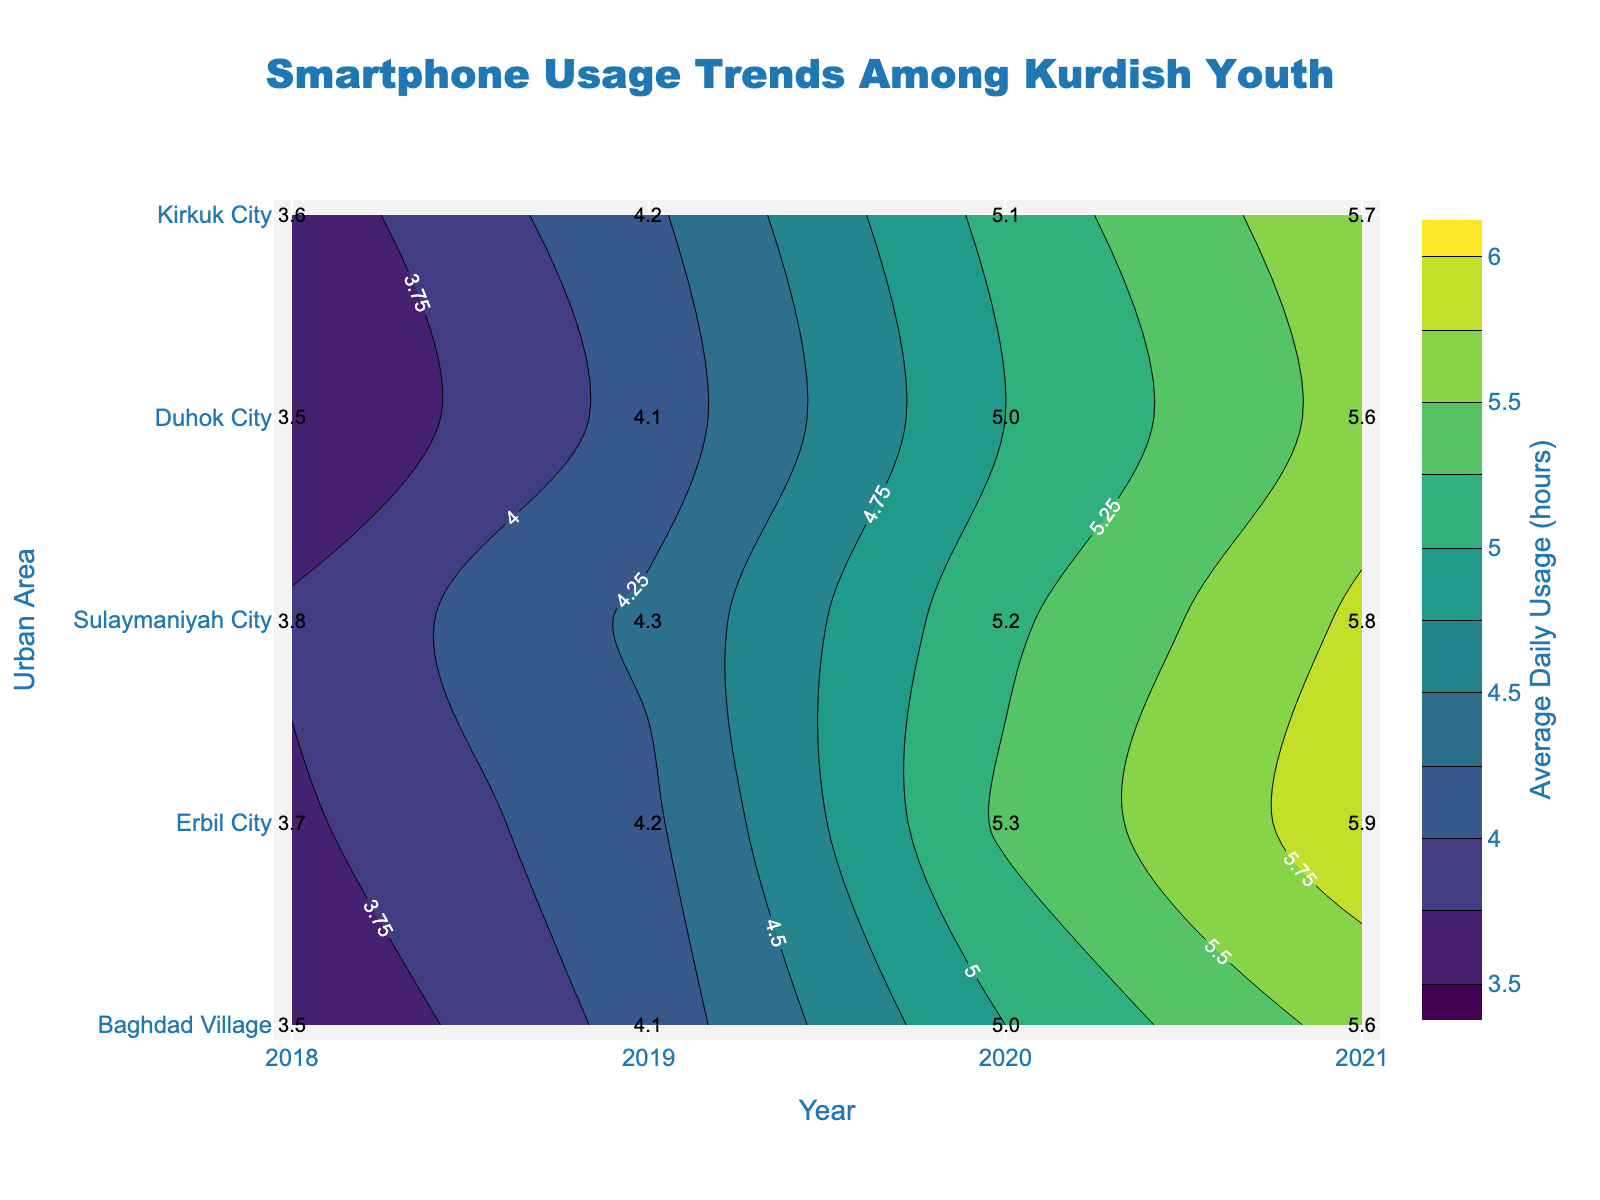What's the title of the figure? The title of the figure is situated at the top center. It's usually larger in size and often in bold to stand out.
Answer: Smartphone Usage Trends Among Kurdish Youth What do the x and y axes represent? The x-axis represents the years (2018 to 2021), and the y-axis represents different urban areas. This information can be found by reading the axis labels.
Answer: Years and Urban Areas Which urban area showed the highest average daily smartphone usage in 2021? Check the values in the 2021 column for all urban areas, and find the maximum value. For instance, Duhok City has the highest value of 5.9 hours in 2021.
Answer: Duhok City How does the average daily smartphone usage in Kirkuk City change from 2018 to 2021? For Kirkuk City, trace the values across the years 2018 to 2021 and note the changes: 3.5 (2018), 4.1 (2019), 5.0 (2020), 5.6 (2021).
Answer: 3.5 to 5.6 hours Which year had the biggest increase in average daily usage across all urban areas? Compare the year-on-year changes for all urban areas and identify the year with the most significant increase. For example, 2019-2020 has a noticeable increase in many urban areas.
Answer: 2020 On average, how much did the usage increase per year in Sulaymaniyah City from 2018 to 2021? Calculate the difference in usage per year, then average these values: (4.2-3.6) for 2019, (5.1-4.2) for 2020, (5.7-5.1) for 2021. Average these increases: (0.6 + 0.9 + 0.6) / 3.
Answer: 0.7 hours/year Between Baghdad Village and Erbil City, which area showed more consistent growth in smartphone usage from 2018 to 2021? Consistency in growth means less fluctuation in yearly increases. Compare the yearly values: Baghdad Village (3.5, 4.1, 5.0, 5.6) and Erbil City (3.8, 4.3, 5.2, 5.8). Calculate the yearly changes and compare their fluctuations.
Answer: Erbil City Which geographical area in 2018 had the smallest smartphone usage compared to its subsequent years? Compare the 2018 values with subsequent years for each urban area, identifying the region with the smallest initial value but a significant increase later.
Answer: Baghdad Village Is there any urban area that showed a decreasing trend in average daily smartphone usage? Check all urban areas year by year; if there's no drop in numbers for any year, then no urban area shows a decreasing trend.
Answer: No 